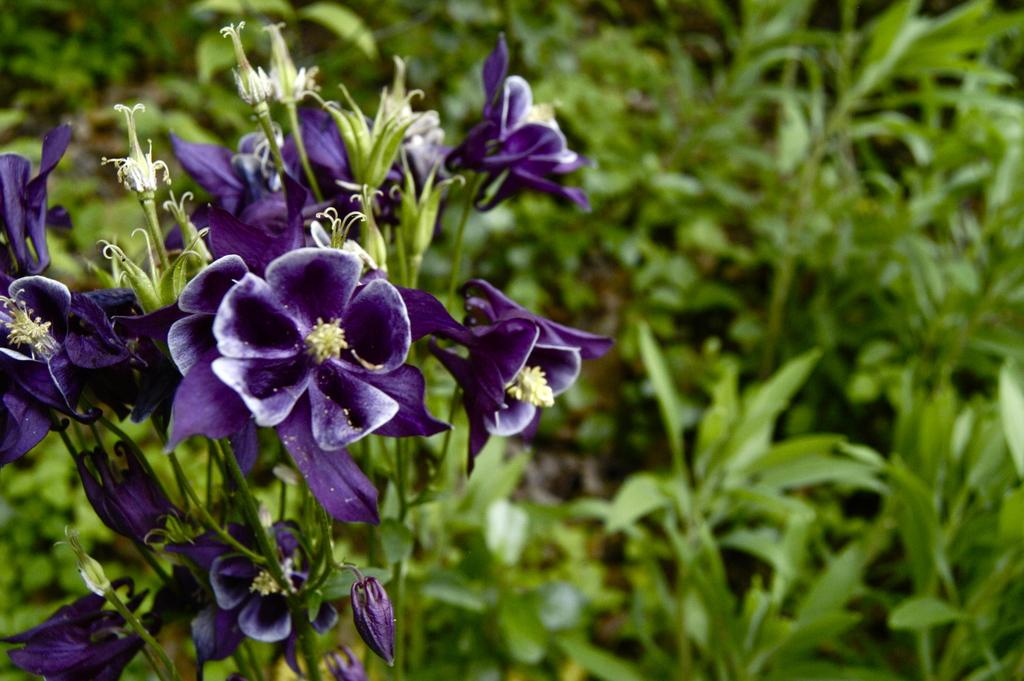What is located in the foreground of the image? There are flowers and a plant in the foreground of the image. What can be seen in the background of the image? The background of the image is blurred, but there is greenery visible. Can you describe the type of vegetation in the foreground? The foreground features flowers and a plant. How many hours of sleep does the plant require in the image? Plants do not require sleep, so this question cannot be answered based on the information provided. 